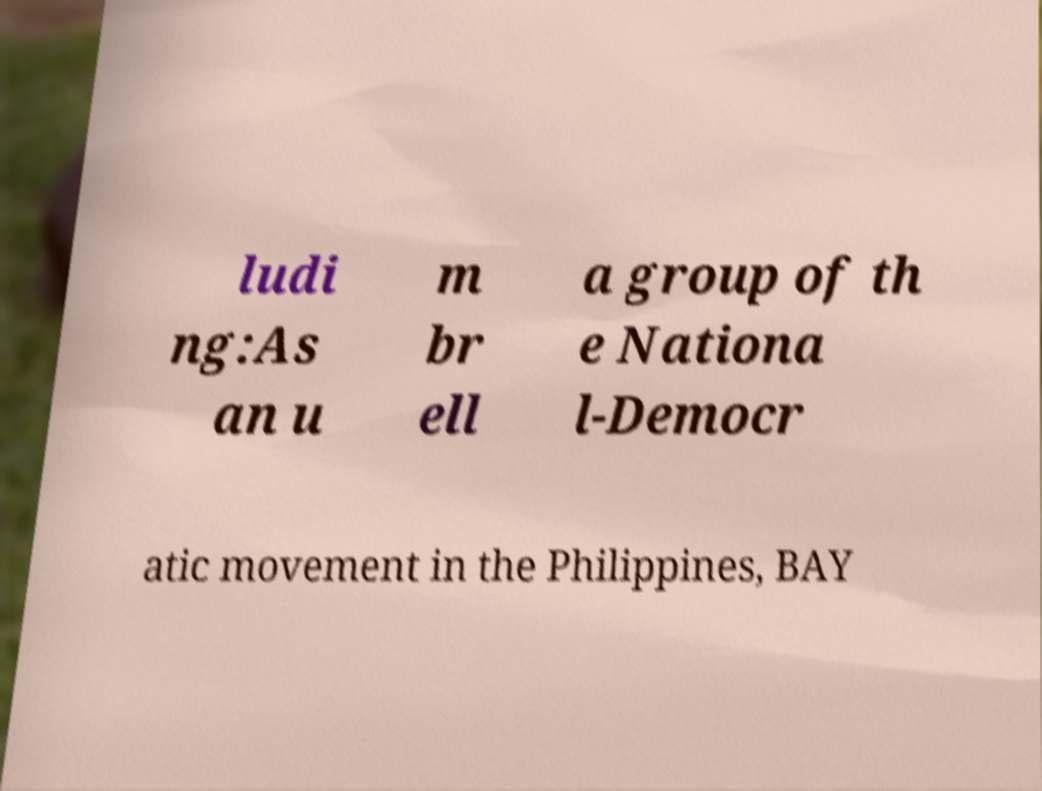Could you assist in decoding the text presented in this image and type it out clearly? ludi ng:As an u m br ell a group of th e Nationa l-Democr atic movement in the Philippines, BAY 